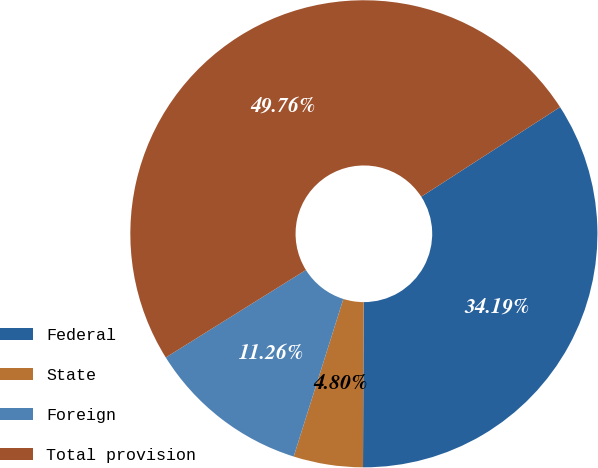<chart> <loc_0><loc_0><loc_500><loc_500><pie_chart><fcel>Federal<fcel>State<fcel>Foreign<fcel>Total provision<nl><fcel>34.19%<fcel>4.8%<fcel>11.26%<fcel>49.76%<nl></chart> 